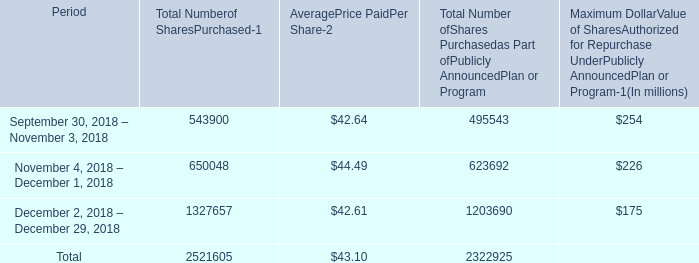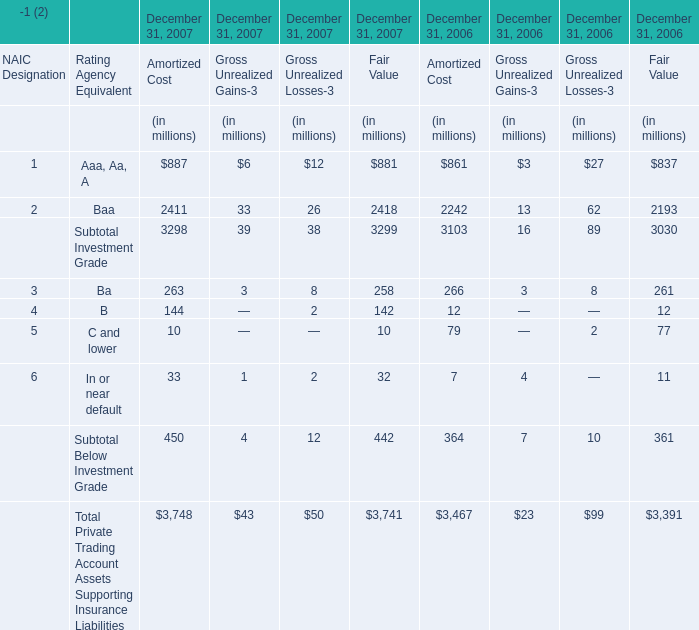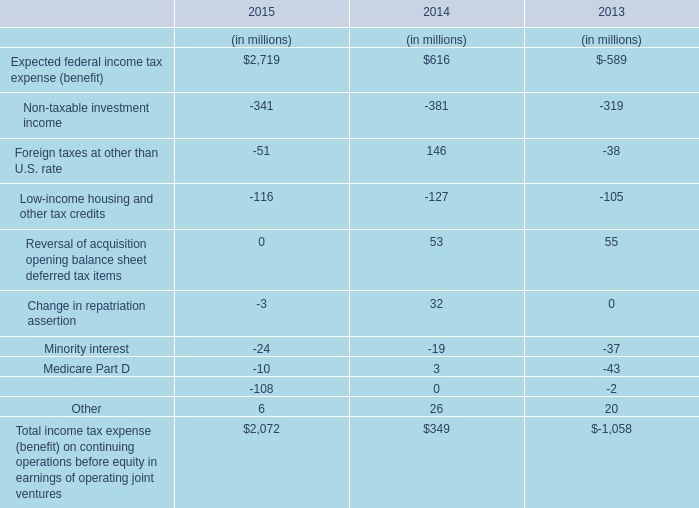how is net change in cash from financing activity affected by the share repurchase during december 20018 , ( in millions ) ? 
Computations: ((1327657 * 42.61) / 1000000)
Answer: 56.57146. 